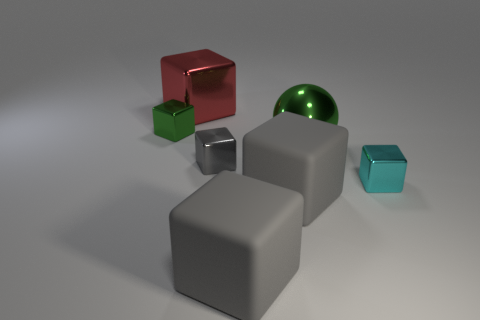Subtract all gray blocks. How many were subtracted if there are1gray blocks left? 2 Subtract all large gray cubes. How many cubes are left? 4 Add 3 large things. How many objects exist? 10 Subtract all red blocks. How many blocks are left? 5 Subtract all blocks. How many objects are left? 1 Subtract all metal balls. Subtract all brown cylinders. How many objects are left? 6 Add 3 green cubes. How many green cubes are left? 4 Add 5 purple rubber cylinders. How many purple rubber cylinders exist? 5 Subtract 0 yellow spheres. How many objects are left? 7 Subtract 4 blocks. How many blocks are left? 2 